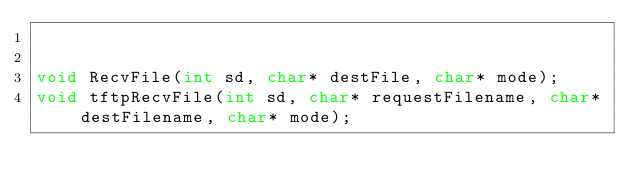<code> <loc_0><loc_0><loc_500><loc_500><_C_>

void RecvFile(int sd, char* destFile, char* mode);
void tftpRecvFile(int sd, char* requestFilename, char* destFilename, char* mode);
</code> 